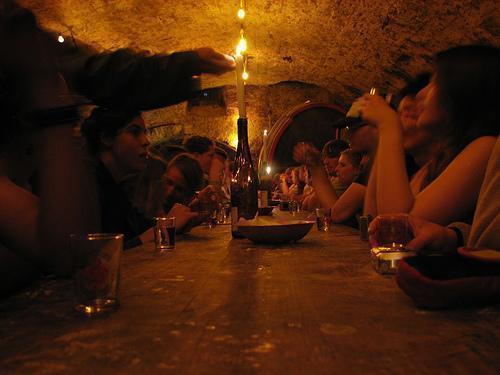What is the name for this style of table?
Answer the question by selecting the correct answer among the 4 following choices.
Options: Elongated table, long table, rectangle table, refectory table. Refectory table. 